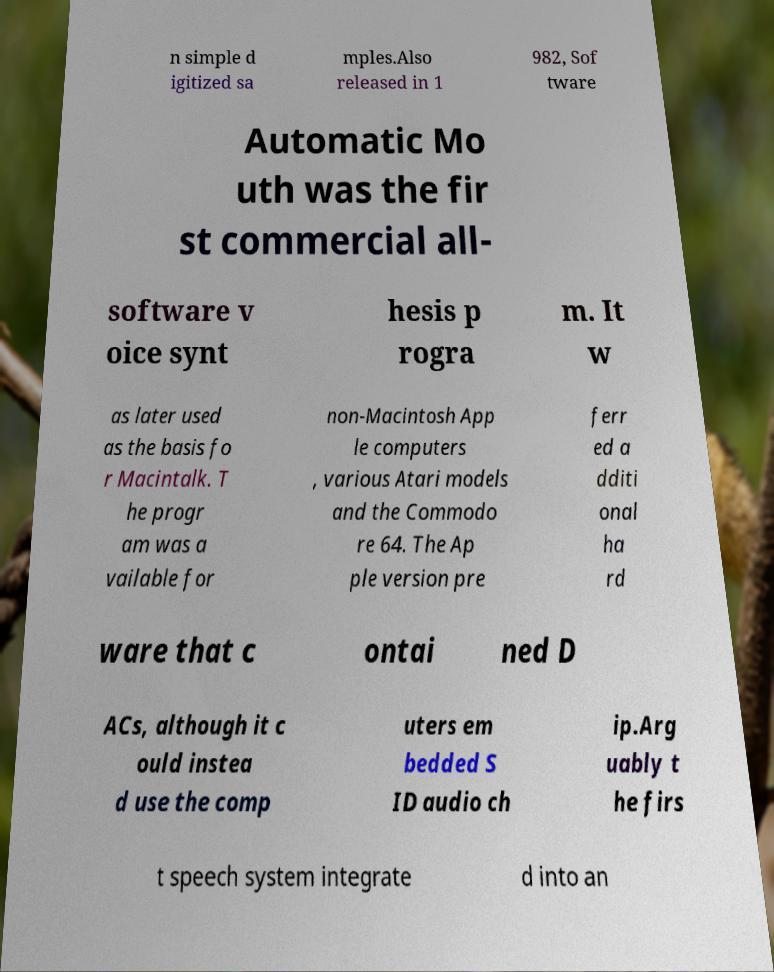Please read and relay the text visible in this image. What does it say? n simple d igitized sa mples.Also released in 1 982, Sof tware Automatic Mo uth was the fir st commercial all- software v oice synt hesis p rogra m. It w as later used as the basis fo r Macintalk. T he progr am was a vailable for non-Macintosh App le computers , various Atari models and the Commodo re 64. The Ap ple version pre ferr ed a dditi onal ha rd ware that c ontai ned D ACs, although it c ould instea d use the comp uters em bedded S ID audio ch ip.Arg uably t he firs t speech system integrate d into an 